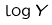<formula> <loc_0><loc_0><loc_500><loc_500>\log Y</formula> 